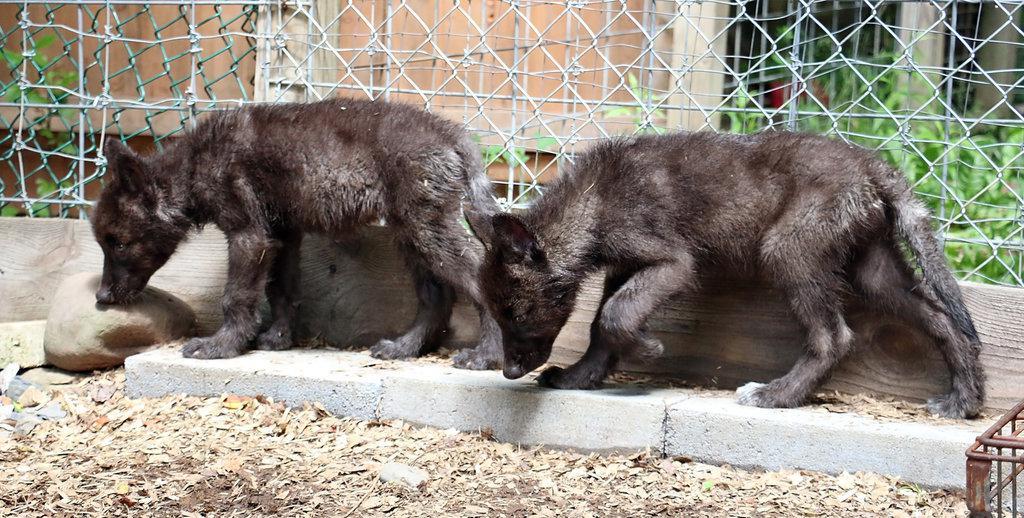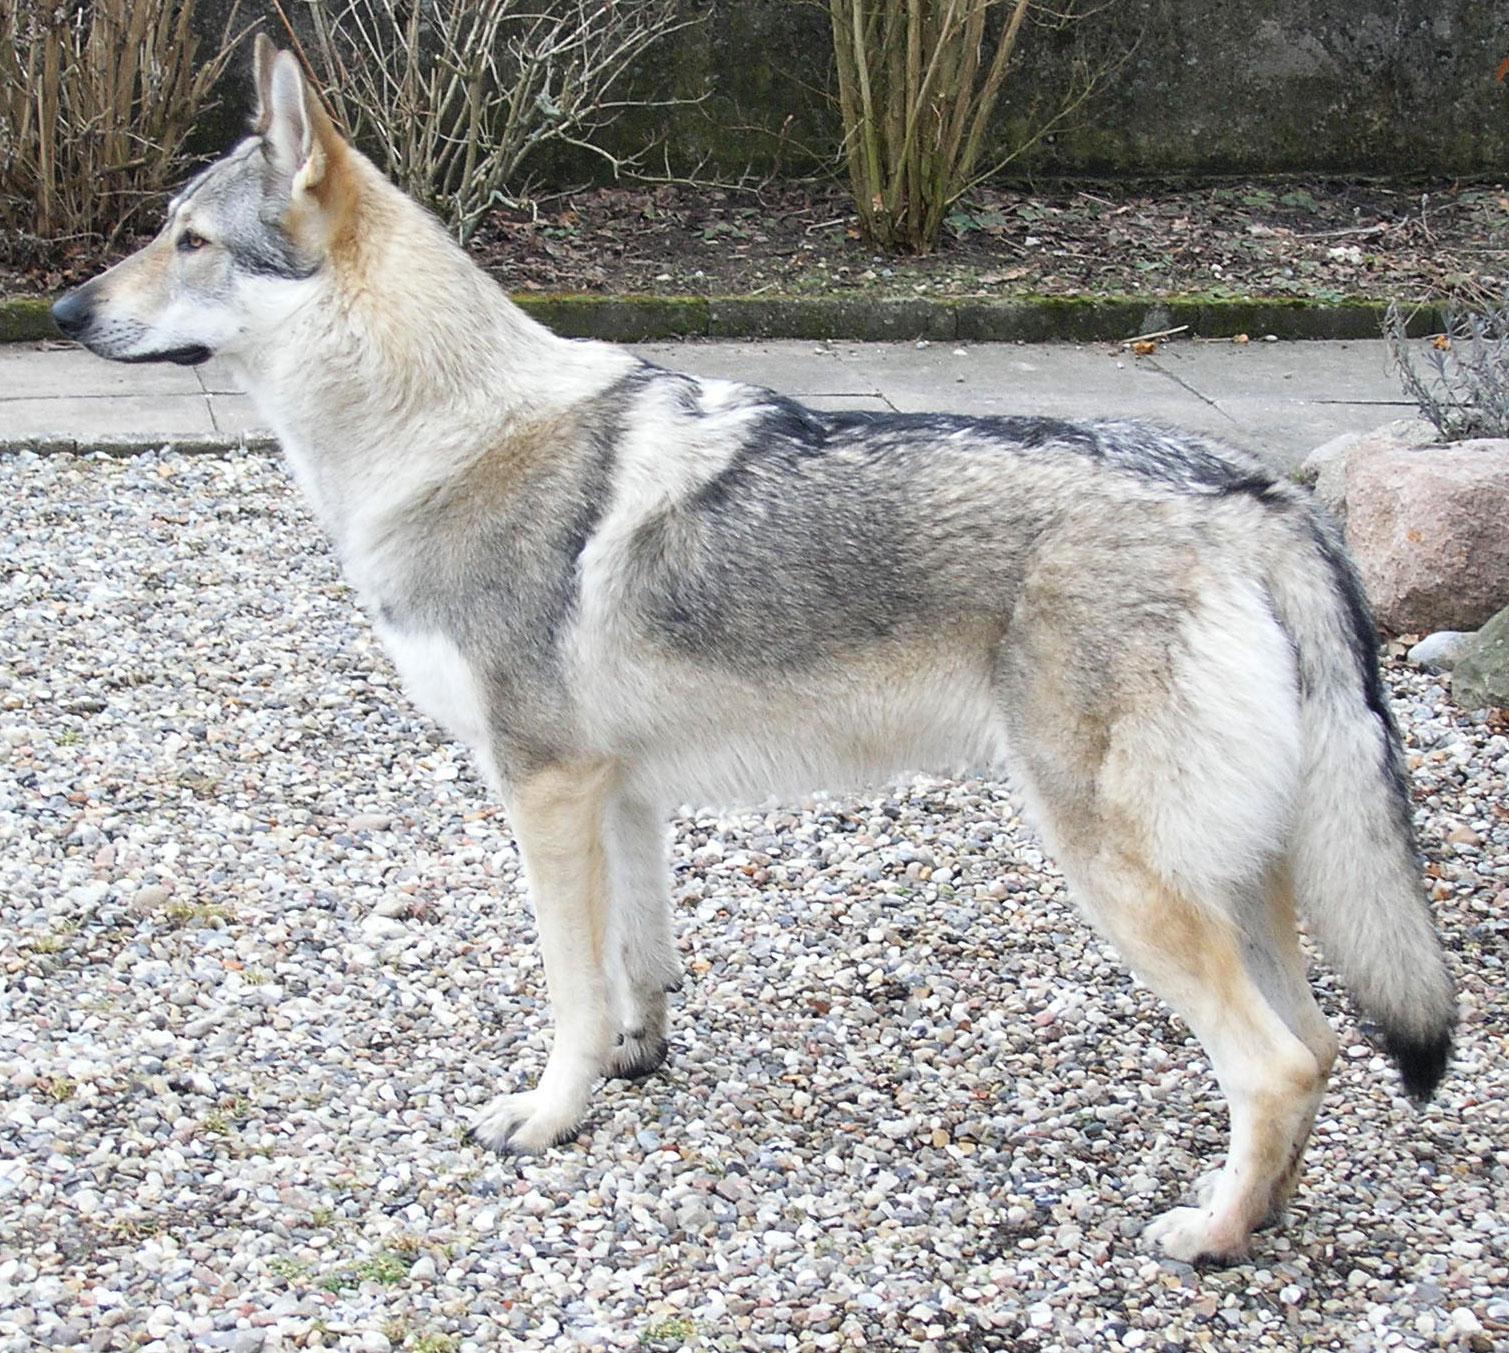The first image is the image on the left, the second image is the image on the right. Analyze the images presented: Is the assertion "There are three wolves in the image pair." valid? Answer yes or no. Yes. The first image is the image on the left, the second image is the image on the right. For the images displayed, is the sentence "One of the images features a single animal." factually correct? Answer yes or no. Yes. 